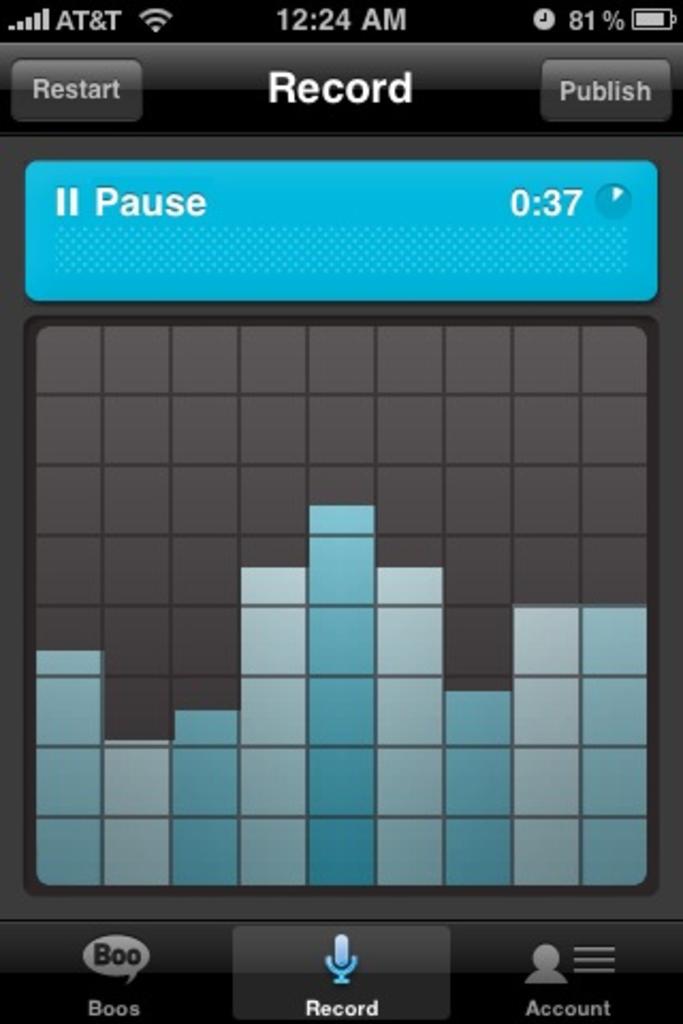What is written on the top left/?
Provide a short and direct response. Restart. 